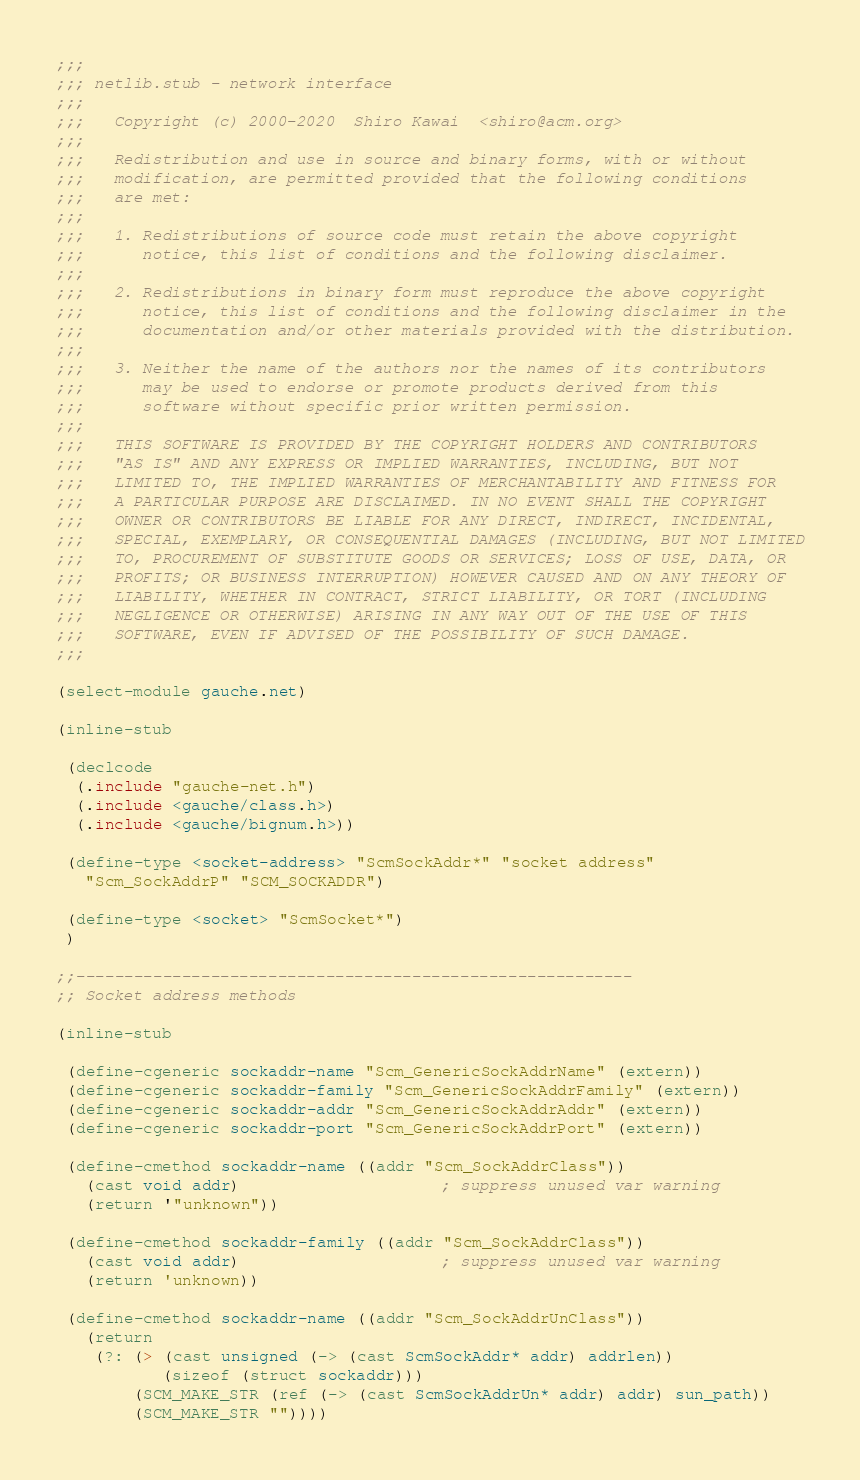Convert code to text. <code><loc_0><loc_0><loc_500><loc_500><_Scheme_>;;;
;;; netlib.stub - network interface
;;;
;;;   Copyright (c) 2000-2020  Shiro Kawai  <shiro@acm.org>
;;;
;;;   Redistribution and use in source and binary forms, with or without
;;;   modification, are permitted provided that the following conditions
;;;   are met:
;;;
;;;   1. Redistributions of source code must retain the above copyright
;;;      notice, this list of conditions and the following disclaimer.
;;;
;;;   2. Redistributions in binary form must reproduce the above copyright
;;;      notice, this list of conditions and the following disclaimer in the
;;;      documentation and/or other materials provided with the distribution.
;;;
;;;   3. Neither the name of the authors nor the names of its contributors
;;;      may be used to endorse or promote products derived from this
;;;      software without specific prior written permission.
;;;
;;;   THIS SOFTWARE IS PROVIDED BY THE COPYRIGHT HOLDERS AND CONTRIBUTORS
;;;   "AS IS" AND ANY EXPRESS OR IMPLIED WARRANTIES, INCLUDING, BUT NOT
;;;   LIMITED TO, THE IMPLIED WARRANTIES OF MERCHANTABILITY AND FITNESS FOR
;;;   A PARTICULAR PURPOSE ARE DISCLAIMED. IN NO EVENT SHALL THE COPYRIGHT
;;;   OWNER OR CONTRIBUTORS BE LIABLE FOR ANY DIRECT, INDIRECT, INCIDENTAL,
;;;   SPECIAL, EXEMPLARY, OR CONSEQUENTIAL DAMAGES (INCLUDING, BUT NOT LIMITED
;;;   TO, PROCUREMENT OF SUBSTITUTE GOODS OR SERVICES; LOSS OF USE, DATA, OR
;;;   PROFITS; OR BUSINESS INTERRUPTION) HOWEVER CAUSED AND ON ANY THEORY OF
;;;   LIABILITY, WHETHER IN CONTRACT, STRICT LIABILITY, OR TORT (INCLUDING
;;;   NEGLIGENCE OR OTHERWISE) ARISING IN ANY WAY OUT OF THE USE OF THIS
;;;   SOFTWARE, EVEN IF ADVISED OF THE POSSIBILITY OF SUCH DAMAGE.
;;;

(select-module gauche.net)

(inline-stub

 (declcode
  (.include "gauche-net.h")
  (.include <gauche/class.h>)
  (.include <gauche/bignum.h>))

 (define-type <socket-address> "ScmSockAddr*" "socket address"
   "Scm_SockAddrP" "SCM_SOCKADDR")

 (define-type <socket> "ScmSocket*")
 )

;;----------------------------------------------------------
;; Socket address methods

(inline-stub

 (define-cgeneric sockaddr-name "Scm_GenericSockAddrName" (extern))
 (define-cgeneric sockaddr-family "Scm_GenericSockAddrFamily" (extern))
 (define-cgeneric sockaddr-addr "Scm_GenericSockAddrAddr" (extern))
 (define-cgeneric sockaddr-port "Scm_GenericSockAddrPort" (extern))

 (define-cmethod sockaddr-name ((addr "Scm_SockAddrClass"))
   (cast void addr)                     ; suppress unused var warning
   (return '"unknown"))

 (define-cmethod sockaddr-family ((addr "Scm_SockAddrClass"))
   (cast void addr)                     ; suppress unused var warning
   (return 'unknown))

 (define-cmethod sockaddr-name ((addr "Scm_SockAddrUnClass"))
   (return
    (?: (> (cast unsigned (-> (cast ScmSockAddr* addr) addrlen))
           (sizeof (struct sockaddr)))
        (SCM_MAKE_STR (ref (-> (cast ScmSockAddrUn* addr) addr) sun_path))
        (SCM_MAKE_STR ""))))
</code> 